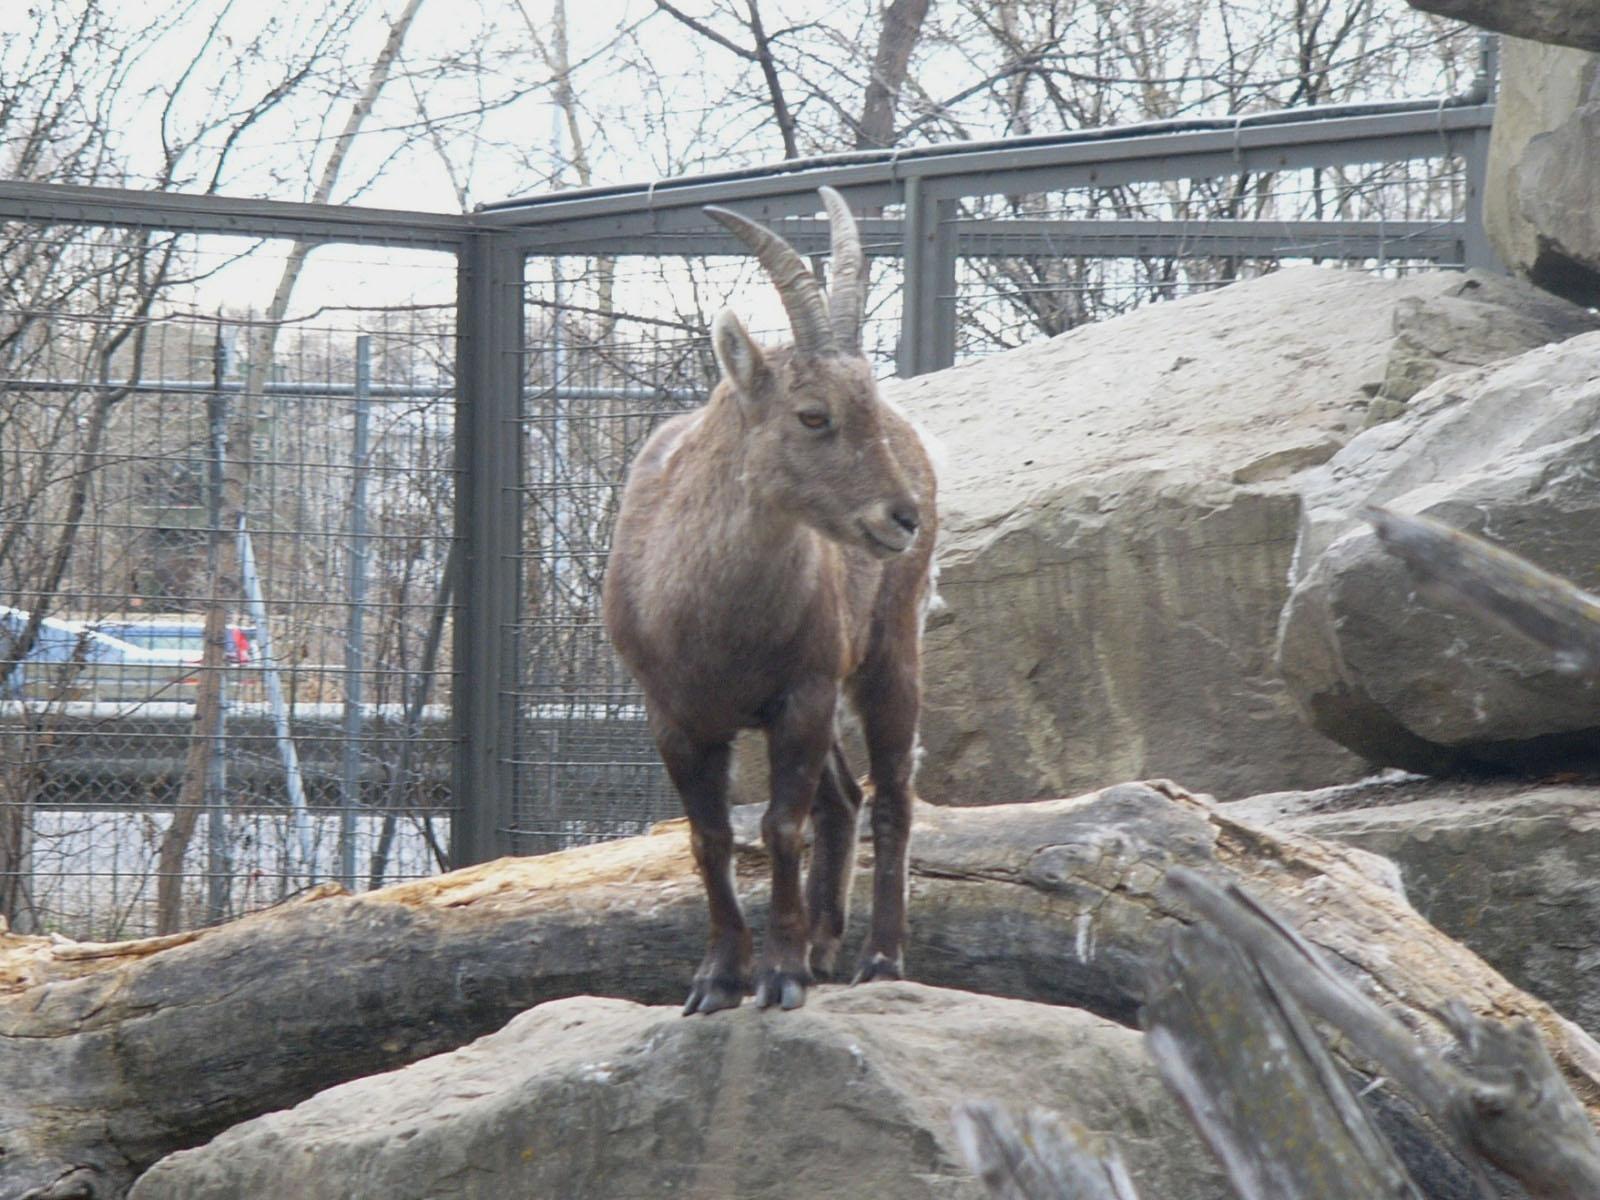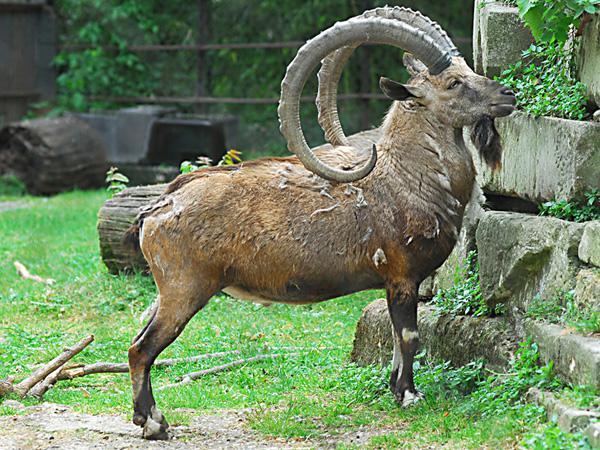The first image is the image on the left, the second image is the image on the right. For the images displayed, is the sentence "The large ram is standing near small rams in one of the images." factually correct? Answer yes or no. No. The first image is the image on the left, the second image is the image on the right. Considering the images on both sides, is "The left and right image contains the same number of goats." valid? Answer yes or no. Yes. 